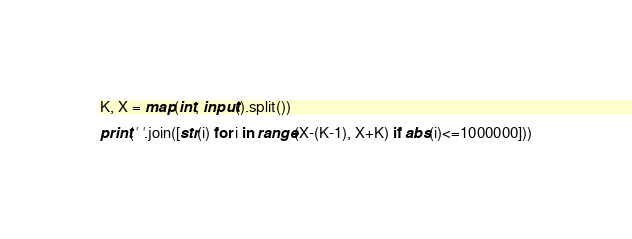<code> <loc_0><loc_0><loc_500><loc_500><_Python_>K, X = map(int, input().split())

print(' '.join([str(i) for i in range(X-(K-1), X+K) if abs(i)<=1000000]))</code> 